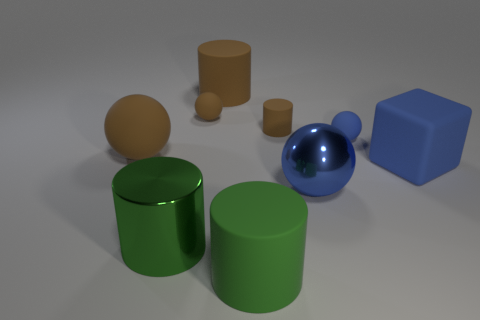Subtract all matte balls. How many balls are left? 1 Subtract all cyan cylinders. How many brown spheres are left? 2 Subtract all cubes. How many objects are left? 8 Subtract 1 cylinders. How many cylinders are left? 3 Subtract 0 red spheres. How many objects are left? 9 Subtract all cyan spheres. Subtract all cyan cubes. How many spheres are left? 4 Subtract all large yellow matte cylinders. Subtract all brown rubber cylinders. How many objects are left? 7 Add 4 large blue metallic spheres. How many large blue metallic spheres are left? 5 Add 1 large green matte cylinders. How many large green matte cylinders exist? 2 